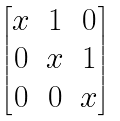<formula> <loc_0><loc_0><loc_500><loc_500>\begin{bmatrix} x & 1 & 0 \\ 0 & x & 1 \\ 0 & 0 & x \\ \end{bmatrix}</formula> 